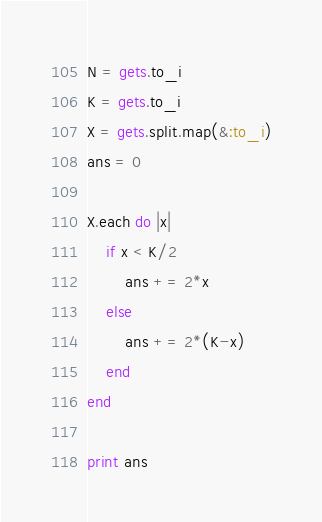<code> <loc_0><loc_0><loc_500><loc_500><_Ruby_>N = gets.to_i
K = gets.to_i
X = gets.split.map(&:to_i)
ans = 0

X.each do |x|
	if x < K/2
		ans += 2*x
	else
		ans += 2*(K-x)
	end
end

print ans
</code> 